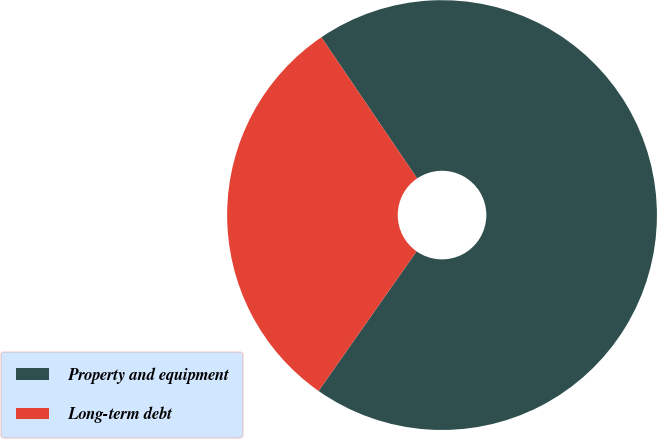<chart> <loc_0><loc_0><loc_500><loc_500><pie_chart><fcel>Property and equipment<fcel>Long-term debt<nl><fcel>69.23%<fcel>30.77%<nl></chart> 